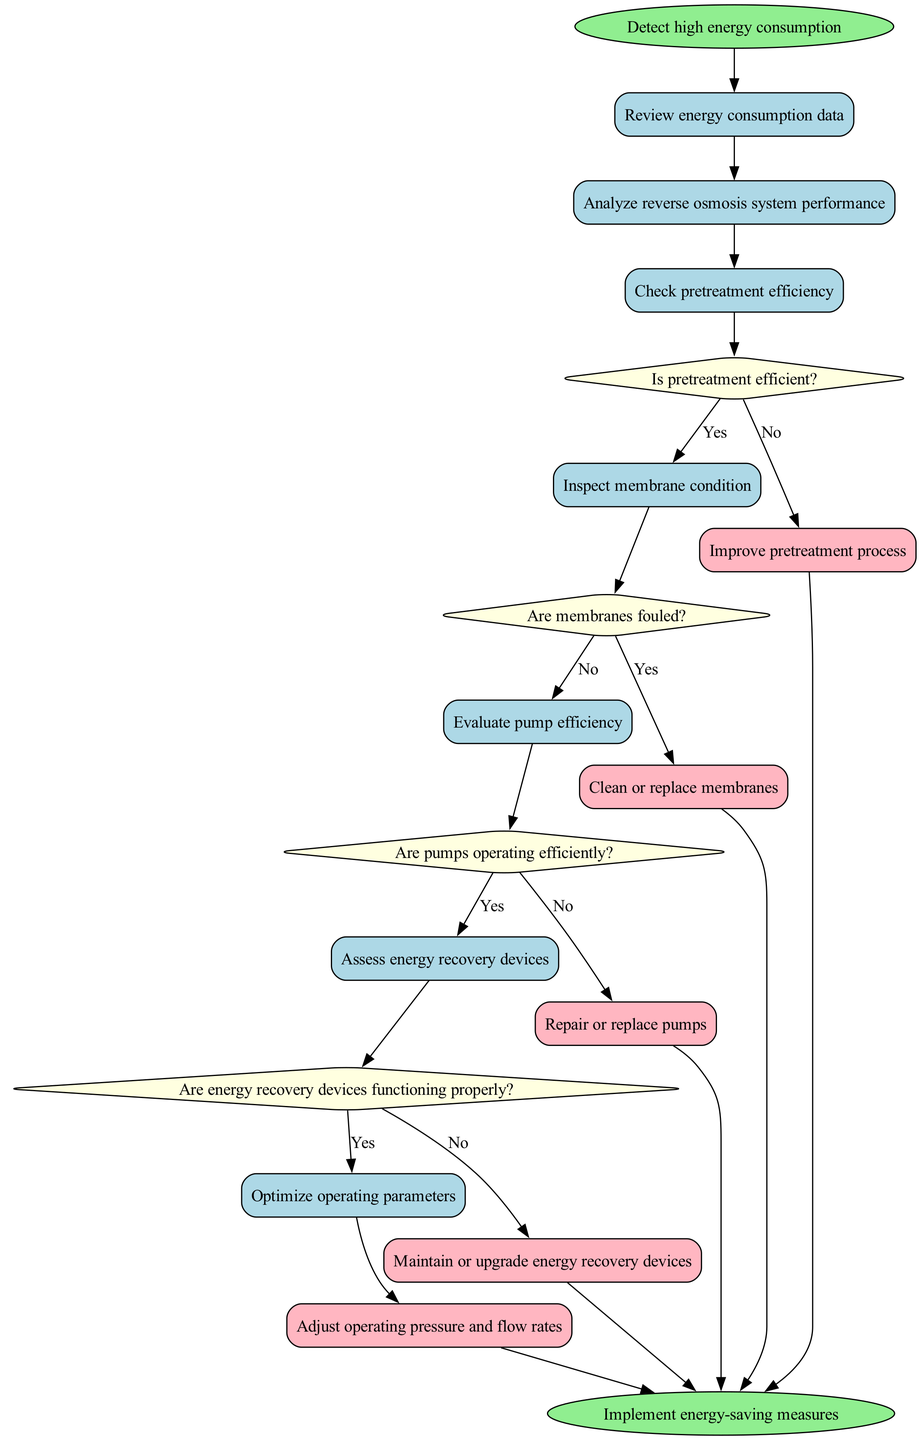What is the first activity in the troubleshooting process? The first activity listed in the diagram is 'Review energy consumption data', which is the first node connected to the start node.
Answer: Review energy consumption data How many actions are there in the diagram? The diagram contains five actions indicated by the nodes labeled as actions.
Answer: 5 Which decision follows the inspection of membrane condition? The decision that follows the inspection of membrane condition is 'Are pumps operating efficiently?' which is directly connected to the inspection activity node.
Answer: Are pumps operating efficiently? What happens if pretreatment is not efficient? If pretreatment is not efficient, the next action is 'Improve pretreatment process', as indicated in the diagram where a 'No' edge leads from the decision to this action.
Answer: Improve pretreatment process Is there an activity that assesses energy recovery devices? Yes, the activity that assesses energy recovery devices is 'Assess energy recovery devices', which occurs after evaluating pump efficiency when membranes are not fouled.
Answer: Assess energy recovery devices What is the final node in the troubleshooting process? The final node in the process is labeled 'Implement energy-saving measures', which indicates the end of the troubleshooting sequence.
Answer: Implement energy-saving measures What is the flow of actions if pumps are operating efficiently? If the pumps are operating efficiently, the flow of actions leads to 'Maintain or upgrade energy recovery devices', arising from the decision that inquires about pump efficiency yielding a 'Yes' answer.
Answer: Maintain or upgrade energy recovery devices Which step directly follows cleaning or replacing membranes? After cleaning or replacing membranes, the next step is 'Assess energy recovery devices', as indicated by the flow from one action to the next in the diagram.
Answer: Assess energy recovery devices Are there any decisions that lead to the same action? Yes, both 'Are membranes fouled?' and 'Are energy recovery devices functioning properly?' decisions can lead to the same conclusion of needing to take actions if their respective conditions are not met.
Answer: Yes, actions can repeat from different decisions 